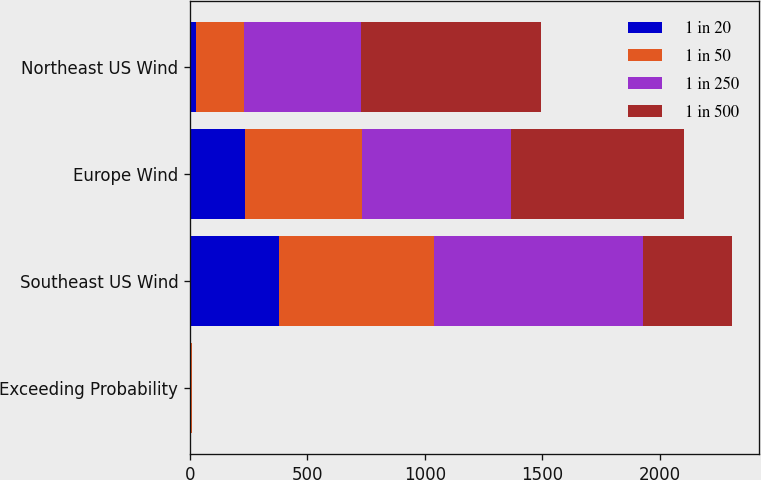<chart> <loc_0><loc_0><loc_500><loc_500><stacked_bar_chart><ecel><fcel>Exceeding Probability<fcel>Southeast US Wind<fcel>Europe Wind<fcel>Northeast US Wind<nl><fcel>1 in 20<fcel>5<fcel>379<fcel>233<fcel>25<nl><fcel>1 in 50<fcel>2<fcel>660<fcel>499<fcel>205<nl><fcel>1 in 250<fcel>1<fcel>888<fcel>635<fcel>500<nl><fcel>1 in 500<fcel>0.4<fcel>379<fcel>737<fcel>765<nl></chart> 